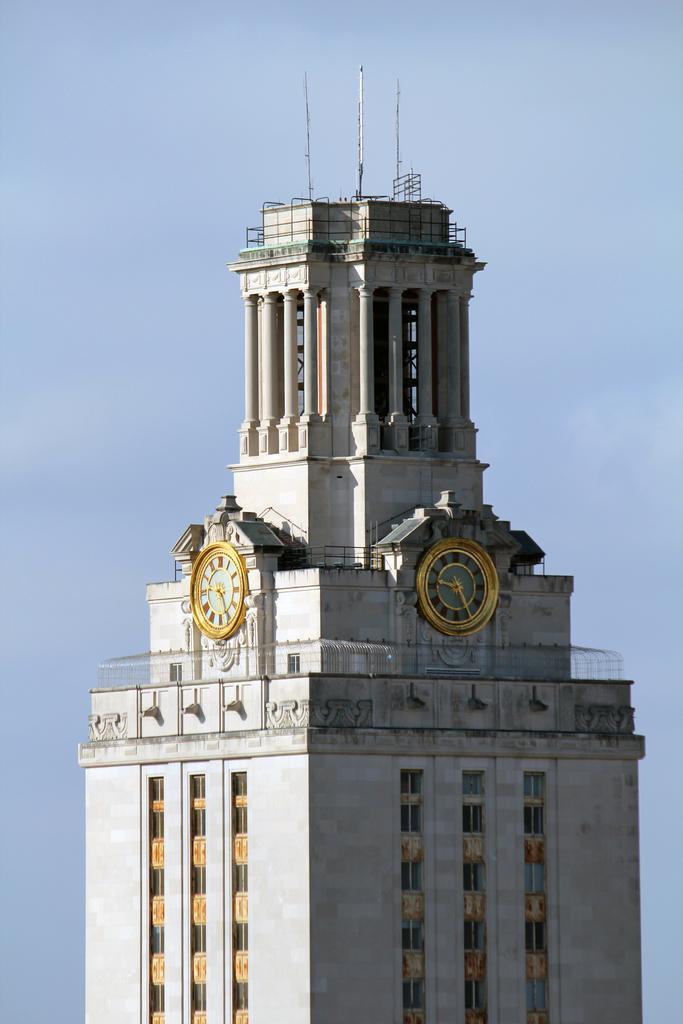How would you summarize this image in a sentence or two? In the center of the image there is a clock tower. In the background there is sky. 